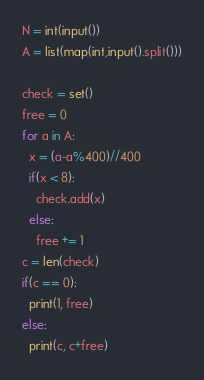Convert code to text. <code><loc_0><loc_0><loc_500><loc_500><_Python_>N = int(input())
A = list(map(int,input().split()))

check = set()
free = 0
for a in A:
  x = (a-a%400)//400
  if(x < 8):
    check.add(x)
  else:
    free += 1
c = len(check) 
if(c == 0):
  print(1, free)
else:
  print(c, c+free)</code> 